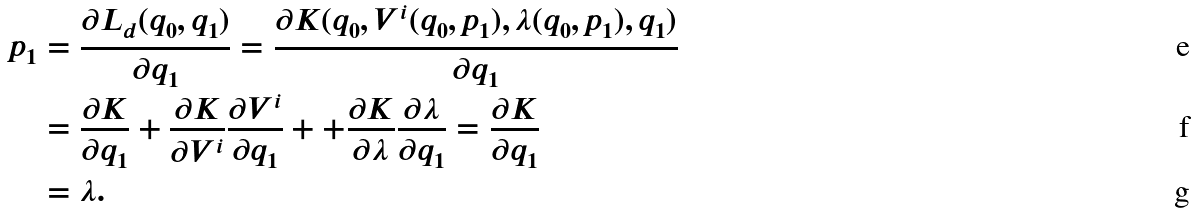<formula> <loc_0><loc_0><loc_500><loc_500>p _ { 1 } & = \frac { \partial L _ { d } ( q _ { 0 } , q _ { 1 } ) } { \partial q _ { 1 } } = \frac { \partial K ( q _ { 0 } , V ^ { i } ( q _ { 0 } , p _ { 1 } ) , \lambda ( q _ { 0 } , p _ { 1 } ) , q _ { 1 } ) } { \partial q _ { 1 } } \\ & = \frac { \partial K } { \partial q _ { 1 } } + \frac { \partial K } { \partial V ^ { i } } \frac { \partial V ^ { i } } { \partial q _ { 1 } } + + \frac { \partial K } { \partial \lambda } \frac { \partial \lambda } { \partial q _ { 1 } } = \frac { \partial K } { \partial q _ { 1 } } \\ & = \lambda .</formula> 